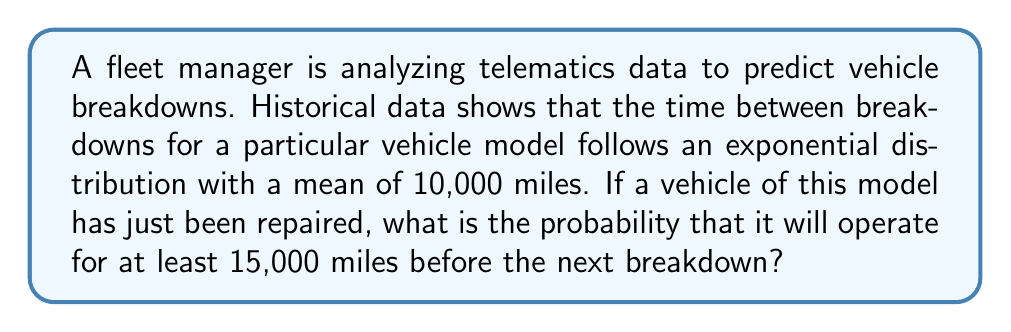Can you answer this question? To solve this problem, we need to use the properties of the exponential distribution, which is commonly used to model the time between events in a Poisson process, such as mechanical failures.

Given:
- The time between breakdowns follows an exponential distribution
- The mean time between breakdowns is 10,000 miles
- We want to find the probability of operating for at least 15,000 miles

Step 1: Identify the parameter of the exponential distribution.
For an exponential distribution, the parameter λ (lambda) is the inverse of the mean. 
$$ \lambda = \frac{1}{\text{mean}} = \frac{1}{10,000} = 0.0001 \text{ per mile} $$

Step 2: Recall the survival function of the exponential distribution.
The survival function S(x) gives the probability that a random variable X is greater than x:
$$ S(x) = P(X > x) = e^{-\lambda x} $$

Step 3: Calculate the probability of operating for at least 15,000 miles.
$$ P(X \geq 15,000) = e^{-\lambda \cdot 15,000} $$
$$ = e^{-0.0001 \cdot 15,000} $$
$$ = e^{-1.5} $$
$$ \approx 0.2231 $$

Therefore, the probability that the vehicle will operate for at least 15,000 miles before the next breakdown is approximately 0.2231 or 22.31%.
Answer: The probability that the vehicle will operate for at least 15,000 miles before the next breakdown is approximately 0.2231 or 22.31%. 